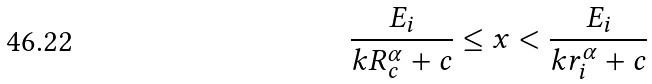<formula> <loc_0><loc_0><loc_500><loc_500>\frac { E _ { i } } { k R _ { c } ^ { \alpha } + c } \leq x < \frac { E _ { i } } { k r _ { i } ^ { \alpha } + c }</formula> 